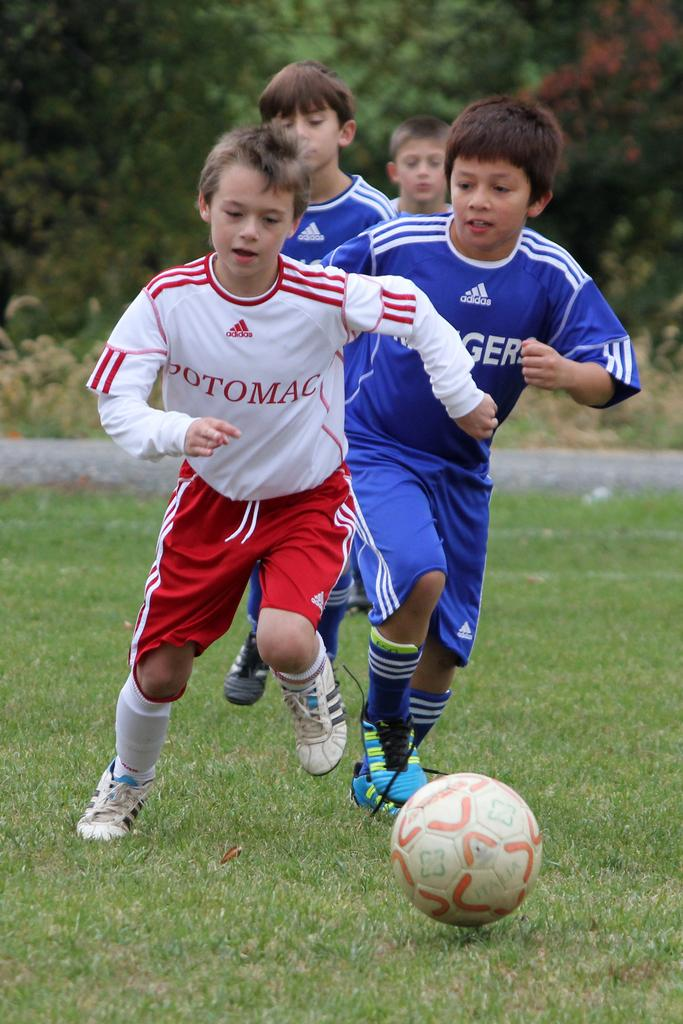How many people are in the image? There are 4 boys in the image. What is the surface the boys are standing on? The boys are on the grass. What object is present in the image that is commonly used in sports? There is a football in the image. What type of soup is being served in the image? There is no soup present in the image. Can you describe the coil-like structure in the image? There is no coil-like structure present in the image. 